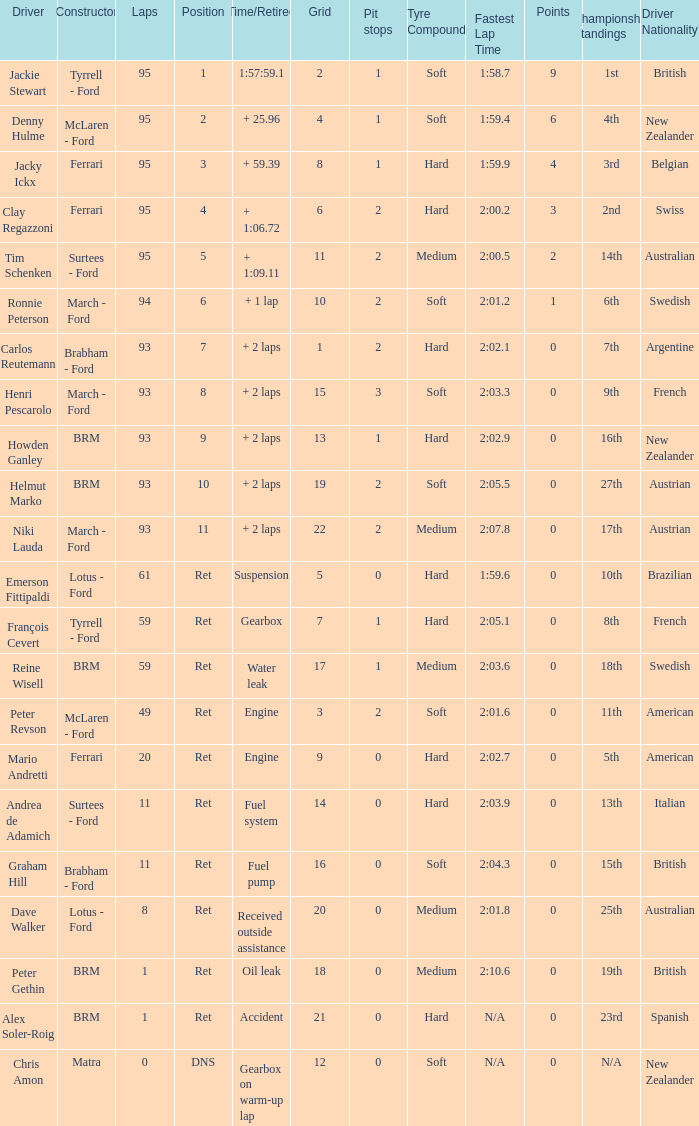What is the total number of grids that dave walker possesses? 1.0. 